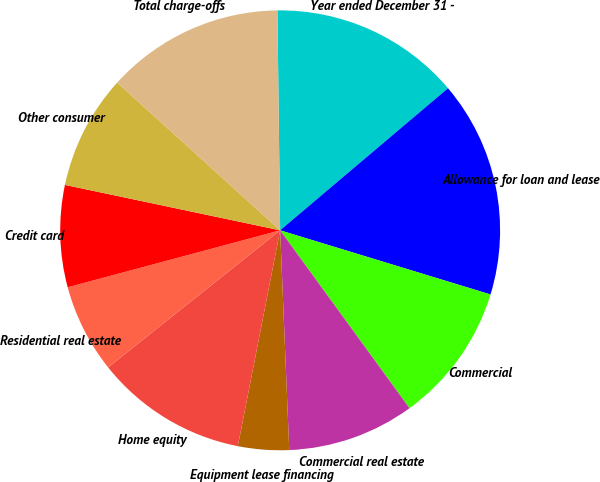Convert chart to OTSL. <chart><loc_0><loc_0><loc_500><loc_500><pie_chart><fcel>Year ended December 31 -<fcel>Allowance for loan and lease<fcel>Commercial<fcel>Commercial real estate<fcel>Equipment lease financing<fcel>Home equity<fcel>Residential real estate<fcel>Credit card<fcel>Other consumer<fcel>Total charge-offs<nl><fcel>14.02%<fcel>15.89%<fcel>10.28%<fcel>9.35%<fcel>3.74%<fcel>11.21%<fcel>6.54%<fcel>7.48%<fcel>8.41%<fcel>13.08%<nl></chart> 